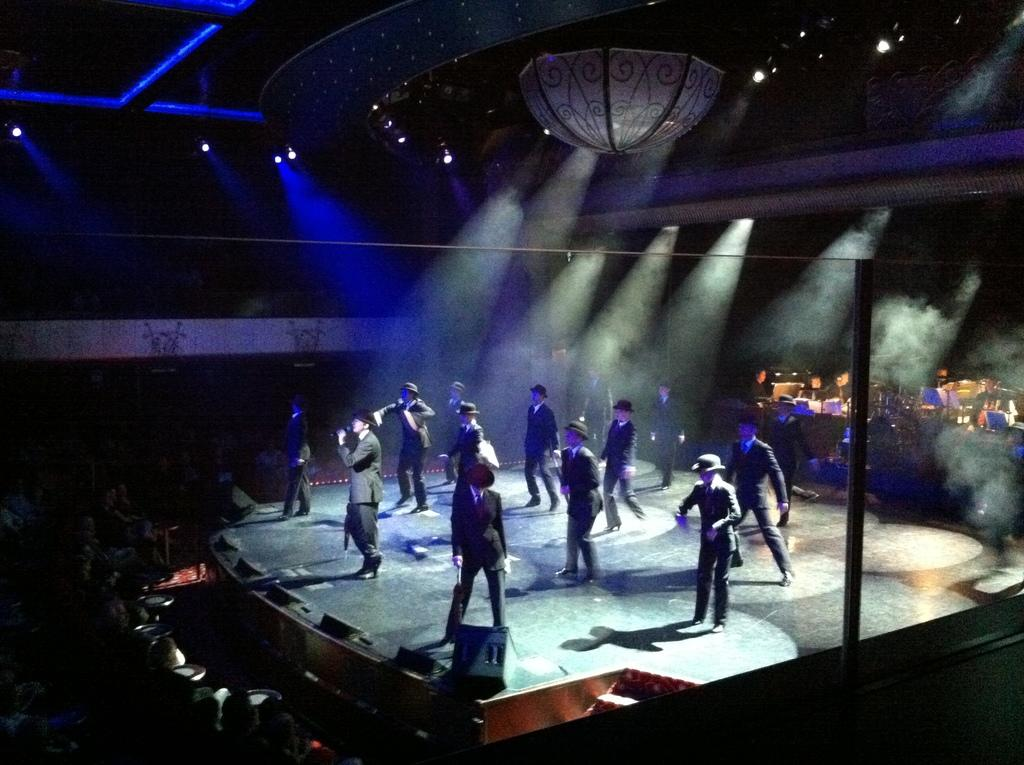What is happening in the image? There is a group of people standing in the image. What are the people wearing on their heads? The people are wearing caps. Can you describe the people in front of the group? There are additional people in front of the group. What can be seen in the background of the image? There is a pole and lights visible in the background. What type of toys are the lawyers using to sit on in the image? There are no toys or lawyers present in the image. How many seats are available for the people in the image? The image does not provide information about the availability of seats for the people. 